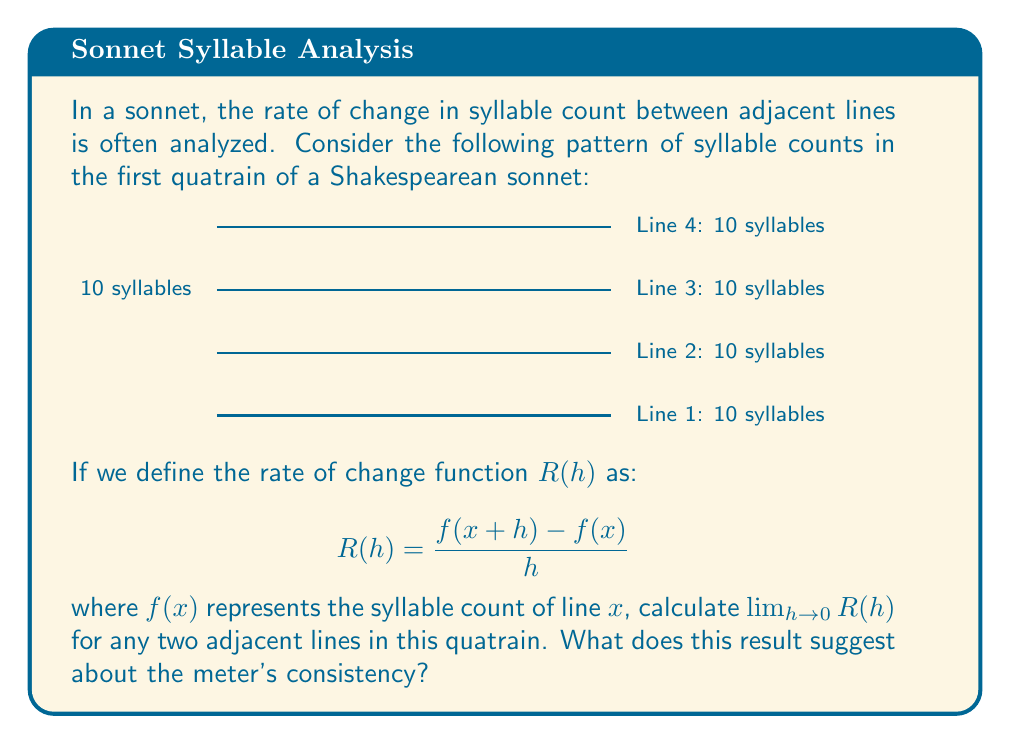Teach me how to tackle this problem. Let's approach this step-by-step:

1) First, we need to understand what $f(x)$ represents. In this case, $f(x)$ is the syllable count for line $x$. For all lines in this quatrain, $f(x) = 10$.

2) Now, let's set up our rate of change function:

   $$R(h) = \frac{f(x+h) - f(x)}{h}$$

3) We can substitute the known values:

   $$R(h) = \frac{10 - 10}{h} = \frac{0}{h}$$

4) Now, we need to evaluate the limit as $h$ approaches 0:

   $$\lim_{h \to 0} R(h) = \lim_{h \to 0} \frac{0}{h} = 0$$

5) The limit exists and equals 0, which means the rate of change between any two adjacent lines is 0.

This result suggests perfect consistency in the meter. The syllable count doesn't change from line to line, indicating a steady, uniform rhythm throughout the quatrain, which is characteristic of the strict metrical pattern in Shakespearean sonnets.
Answer: $\lim_{h \to 0} R(h) = 0$ 